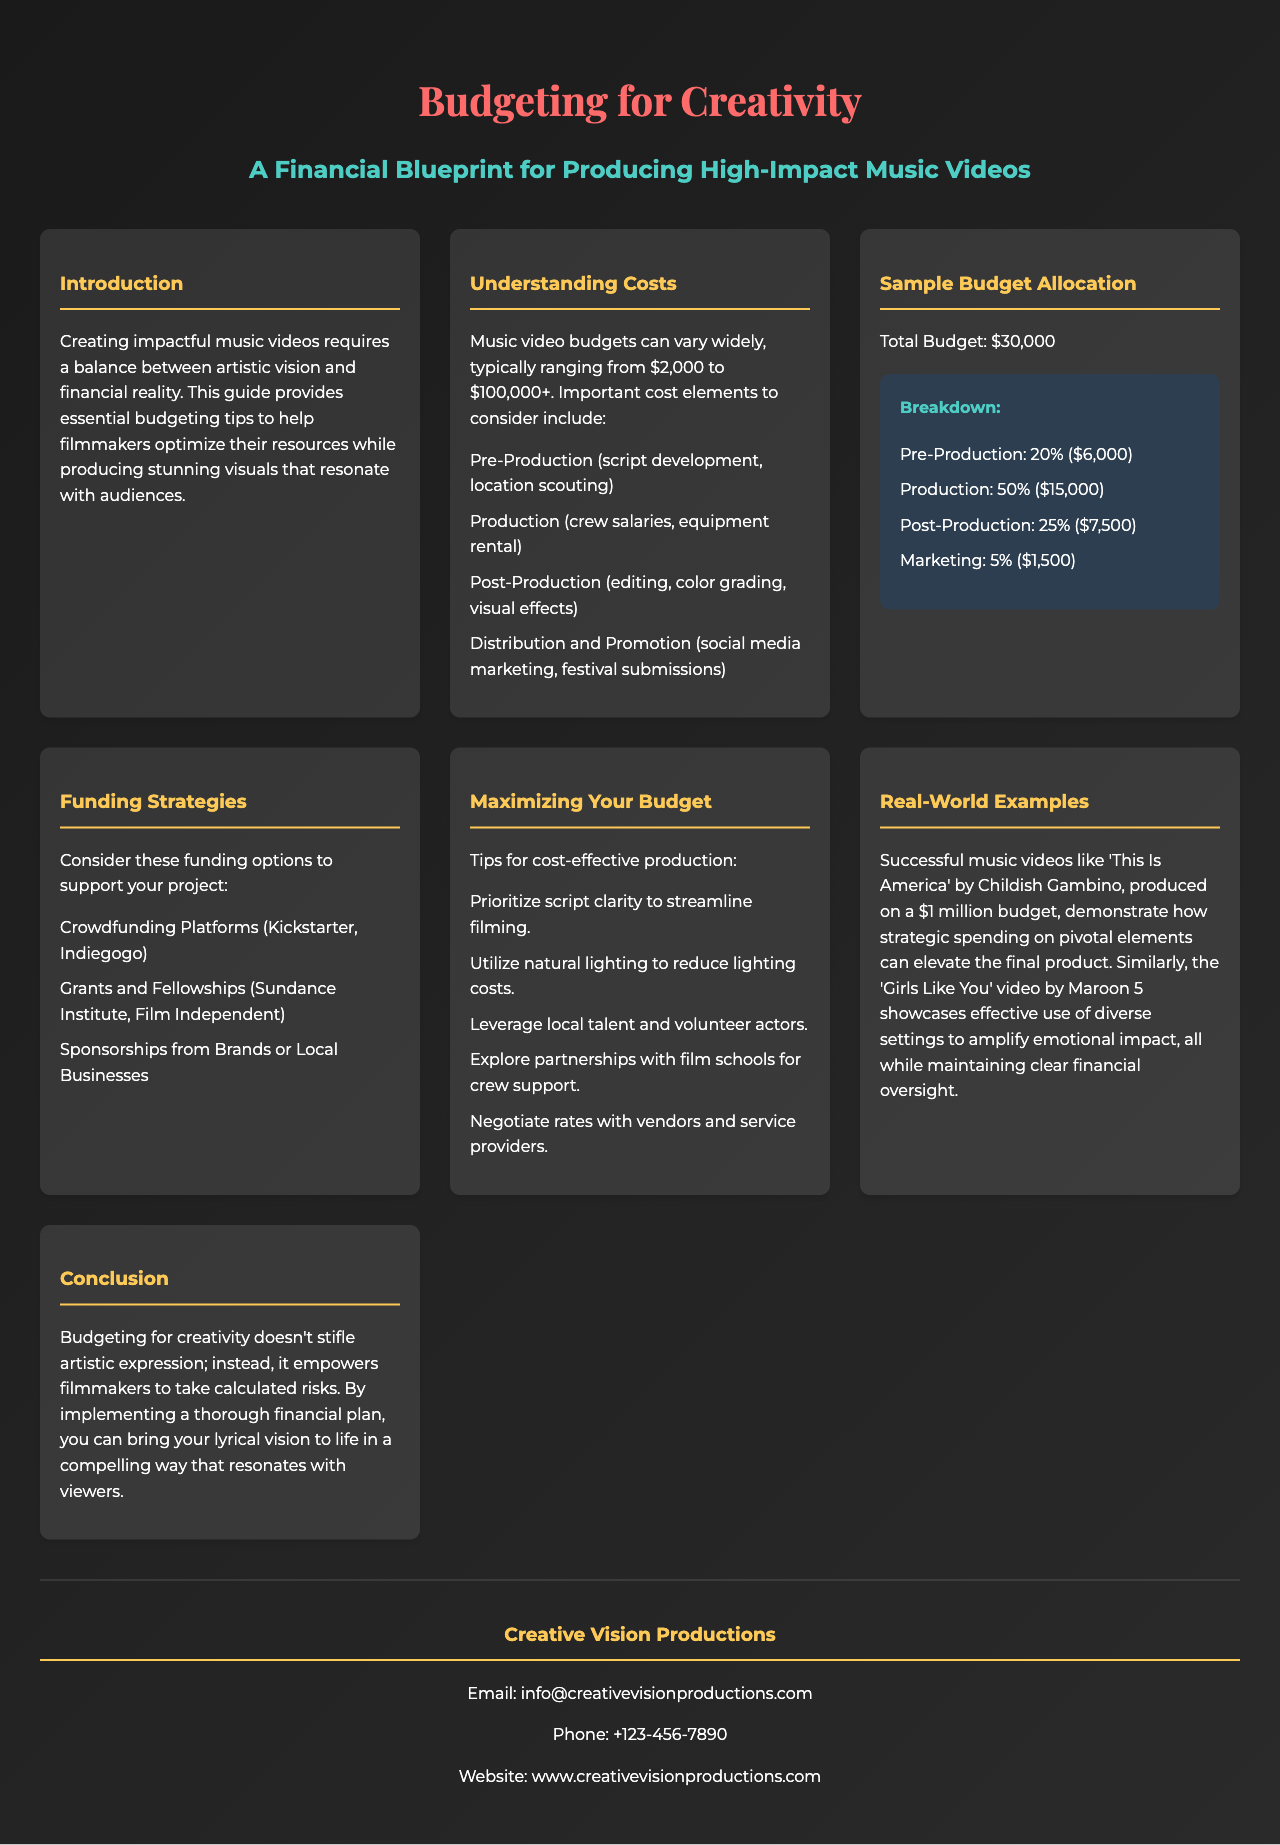What is the total budget for the sample music video? The document states a total budget of $30,000 for the sample music video.
Answer: $30,000 What are the four important cost elements in music video production? The document lists pre-production, production, post-production, and distribution and promotion as the four key cost elements.
Answer: Pre-Production, Production, Post-Production, Distribution and Promotion What percentage of the budget is allocated to production? The budget breakdown shows that 50% of the total budget is allocated to production.
Answer: 50% Which music video is mentioned as produced on a $1 million budget? The document refers to 'This Is America' by Childish Gambino as an example of a successful video produced on a $1 million budget.
Answer: This Is America What funding option involves crowdsourcing? Crowdfunding platforms such as Kickstarter and Indiegogo are mentioned as a funding option that involves crowdsourcing.
Answer: Crowdfunding Platforms What visual elements are emphasized to enhance budget efficiency? The document suggests prioritizing script clarity and utilizing natural lighting to enhance budget efficiency.
Answer: Script clarity, natural lighting What is the purpose of the brochure? The brochure aims to provide essential budgeting tips to help filmmakers optimize their resources in music video production.
Answer: To provide essential budgeting tips What organization is mentioned for grants and fellowships? The Sundance Institute is one of the organizations mentioned in connection with grants and fellowships for filmmakers.
Answer: Sundance Institute How is the conclusion framed regarding budgeting for creativity? The document states that budgeting empowers filmmakers to take calculated risks and enhances artistic expression.
Answer: Empowers filmmakers to take calculated risks 